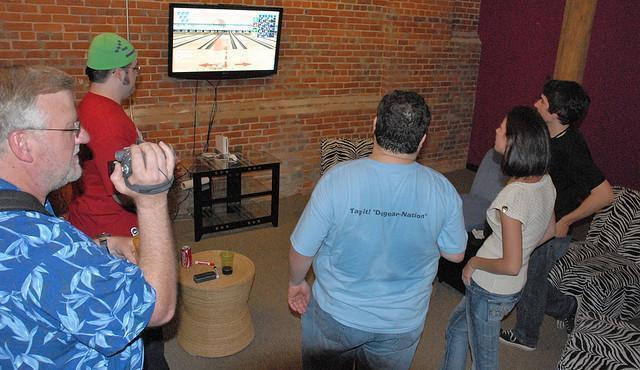Which Wii sport game must be played by the crowd of children in the lounge?
Answer the question by selecting the correct answer among the 4 following choices and explain your choice with a short sentence. The answer should be formatted with the following format: `Answer: choice
Rationale: rationale.`
Options: Golf, boxing, tennis, bowling. Answer: bowling.
Rationale: The people are playing the bowling wii sport game. 